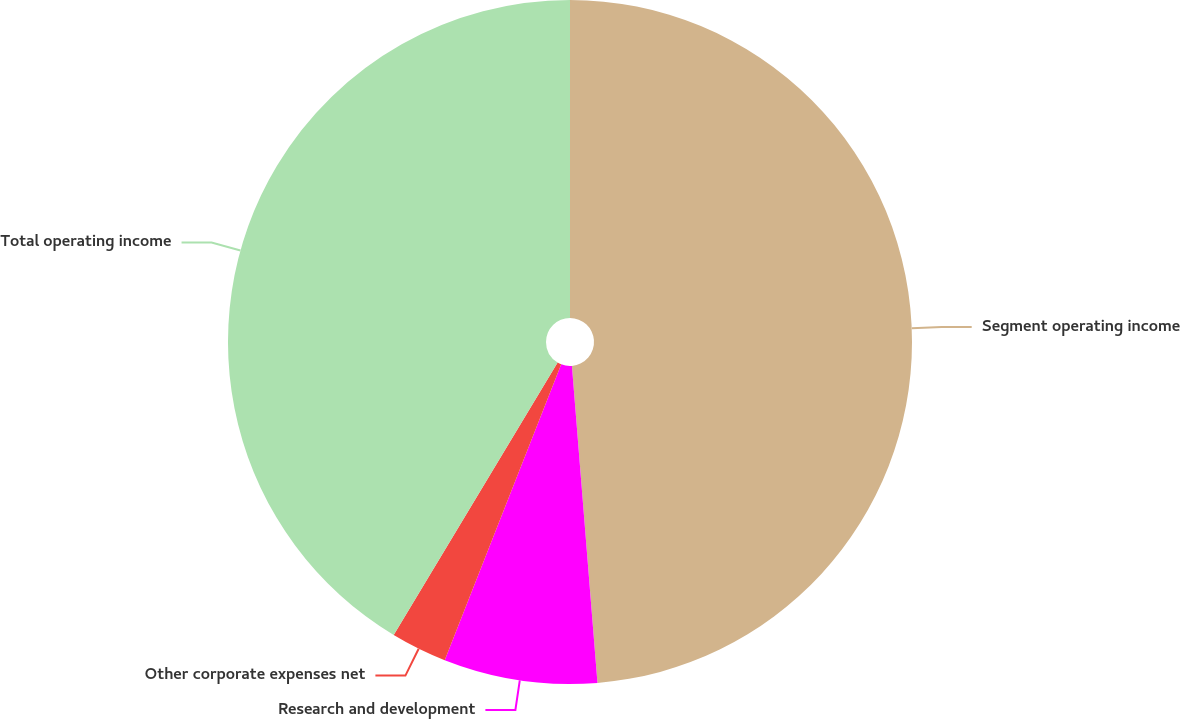<chart> <loc_0><loc_0><loc_500><loc_500><pie_chart><fcel>Segment operating income<fcel>Research and development<fcel>Other corporate expenses net<fcel>Total operating income<nl><fcel>48.72%<fcel>7.25%<fcel>2.65%<fcel>41.38%<nl></chart> 